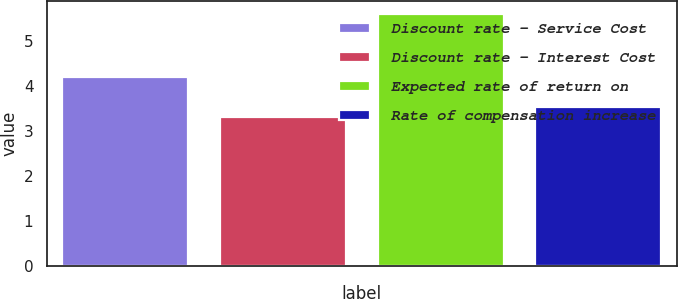<chart> <loc_0><loc_0><loc_500><loc_500><bar_chart><fcel>Discount rate - Service Cost<fcel>Discount rate - Interest Cost<fcel>Expected rate of return on<fcel>Rate of compensation increase<nl><fcel>4.2<fcel>3.3<fcel>5.6<fcel>3.53<nl></chart> 